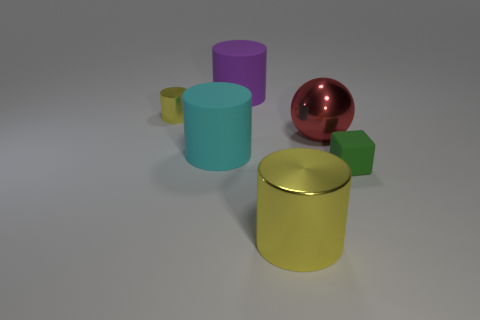How many yellow metallic cylinders are the same size as the green thing?
Make the answer very short. 1. The small cylinder is what color?
Your answer should be very brief. Yellow. There is a small matte block; does it have the same color as the large shiny object on the left side of the red metallic object?
Provide a short and direct response. No. There is a purple object that is the same material as the block; what size is it?
Offer a terse response. Large. Is there a large metallic cylinder of the same color as the tiny metallic thing?
Your response must be concise. Yes. How many objects are either small things that are right of the big metallic cylinder or big purple matte cylinders?
Keep it short and to the point. 2. Are the big yellow object and the large cylinder to the left of the big purple matte thing made of the same material?
Keep it short and to the point. No. The metallic cylinder that is the same color as the small metallic object is what size?
Give a very brief answer. Large. Are there any small cylinders that have the same material as the block?
Offer a very short reply. No. How many things are yellow cylinders that are left of the big yellow metallic thing or metal cylinders that are behind the large metal cylinder?
Your answer should be compact. 1. 